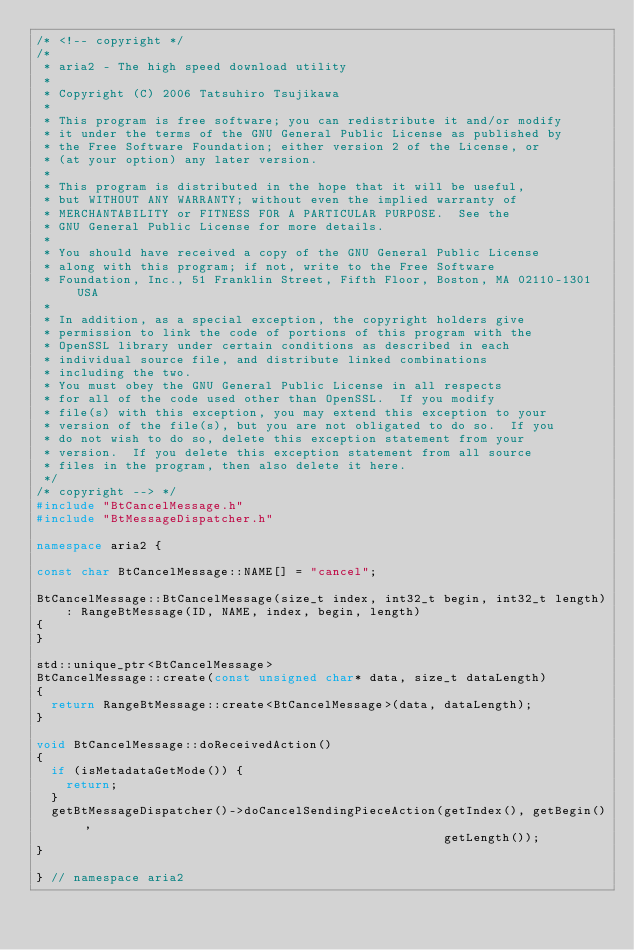Convert code to text. <code><loc_0><loc_0><loc_500><loc_500><_C++_>/* <!-- copyright */
/*
 * aria2 - The high speed download utility
 *
 * Copyright (C) 2006 Tatsuhiro Tsujikawa
 *
 * This program is free software; you can redistribute it and/or modify
 * it under the terms of the GNU General Public License as published by
 * the Free Software Foundation; either version 2 of the License, or
 * (at your option) any later version.
 *
 * This program is distributed in the hope that it will be useful,
 * but WITHOUT ANY WARRANTY; without even the implied warranty of
 * MERCHANTABILITY or FITNESS FOR A PARTICULAR PURPOSE.  See the
 * GNU General Public License for more details.
 *
 * You should have received a copy of the GNU General Public License
 * along with this program; if not, write to the Free Software
 * Foundation, Inc., 51 Franklin Street, Fifth Floor, Boston, MA 02110-1301 USA
 *
 * In addition, as a special exception, the copyright holders give
 * permission to link the code of portions of this program with the
 * OpenSSL library under certain conditions as described in each
 * individual source file, and distribute linked combinations
 * including the two.
 * You must obey the GNU General Public License in all respects
 * for all of the code used other than OpenSSL.  If you modify
 * file(s) with this exception, you may extend this exception to your
 * version of the file(s), but you are not obligated to do so.  If you
 * do not wish to do so, delete this exception statement from your
 * version.  If you delete this exception statement from all source
 * files in the program, then also delete it here.
 */
/* copyright --> */
#include "BtCancelMessage.h"
#include "BtMessageDispatcher.h"

namespace aria2 {

const char BtCancelMessage::NAME[] = "cancel";

BtCancelMessage::BtCancelMessage(size_t index, int32_t begin, int32_t length)
    : RangeBtMessage(ID, NAME, index, begin, length)
{
}

std::unique_ptr<BtCancelMessage>
BtCancelMessage::create(const unsigned char* data, size_t dataLength)
{
  return RangeBtMessage::create<BtCancelMessage>(data, dataLength);
}

void BtCancelMessage::doReceivedAction()
{
  if (isMetadataGetMode()) {
    return;
  }
  getBtMessageDispatcher()->doCancelSendingPieceAction(getIndex(), getBegin(),
                                                       getLength());
}

} // namespace aria2
</code> 